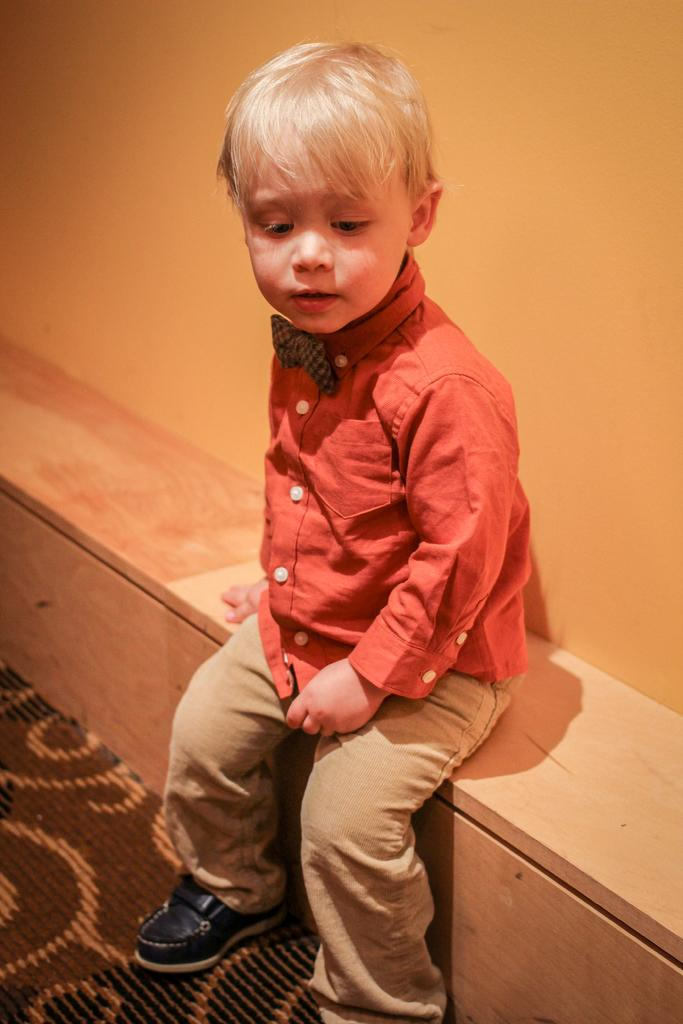Who is in the image? There is a boy in the image. What is the boy wearing? The boy is wearing a red shirt and black shoes. Where is the boy sitting? The boy is sitting on a wooden bench. What color is the wall in the background? The wall is orange in color. What is at the bottom of the image? There is a brown carpet at the bottom of the image. How many beds are visible in the image? There are no beds visible in the image. What type of toe is the boy using to grip the bench? The image does not show the boy's toes or how he is gripping the bench. 